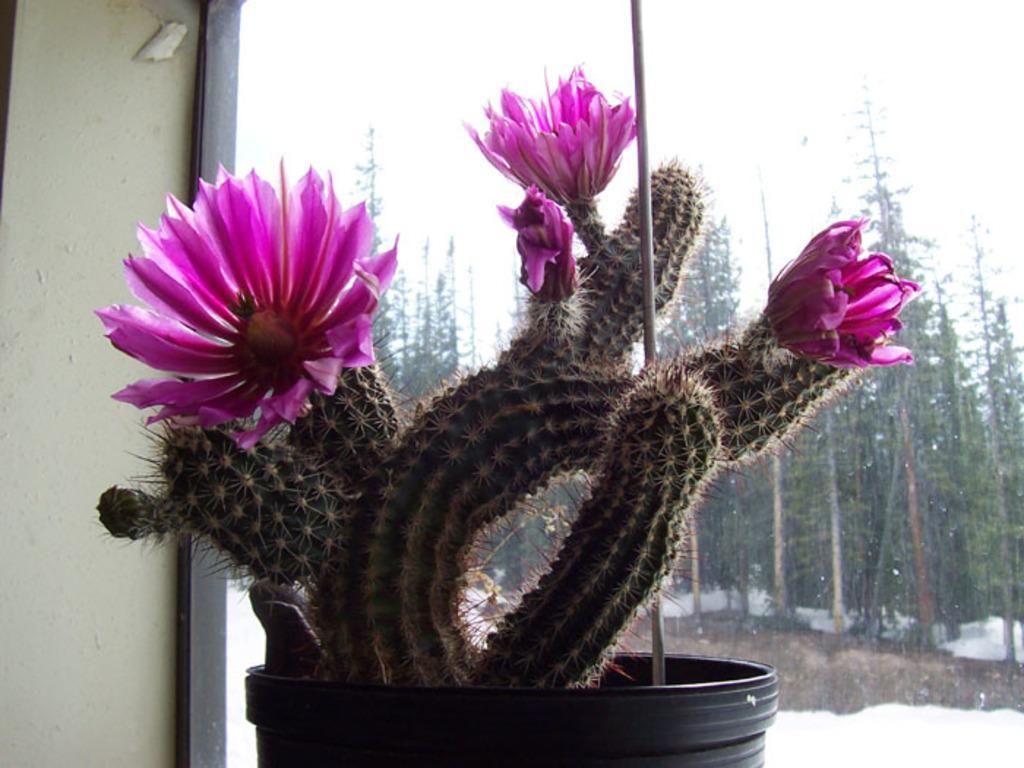In one or two sentences, can you explain what this image depicts? There is a cactus plant with pink flowers on a black pot. There is a small pole near the cactus. There is a window. Through the window we can see trees and snow on the ground. 